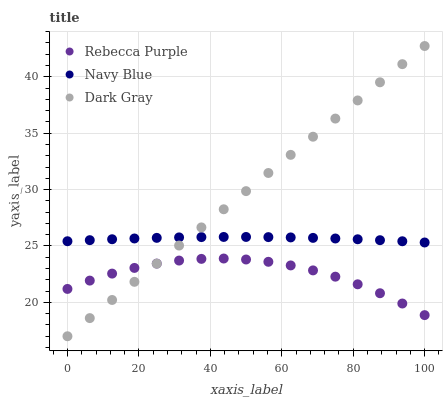Does Rebecca Purple have the minimum area under the curve?
Answer yes or no. Yes. Does Dark Gray have the maximum area under the curve?
Answer yes or no. Yes. Does Navy Blue have the minimum area under the curve?
Answer yes or no. No. Does Navy Blue have the maximum area under the curve?
Answer yes or no. No. Is Dark Gray the smoothest?
Answer yes or no. Yes. Is Rebecca Purple the roughest?
Answer yes or no. Yes. Is Navy Blue the smoothest?
Answer yes or no. No. Is Navy Blue the roughest?
Answer yes or no. No. Does Dark Gray have the lowest value?
Answer yes or no. Yes. Does Rebecca Purple have the lowest value?
Answer yes or no. No. Does Dark Gray have the highest value?
Answer yes or no. Yes. Does Navy Blue have the highest value?
Answer yes or no. No. Is Rebecca Purple less than Navy Blue?
Answer yes or no. Yes. Is Navy Blue greater than Rebecca Purple?
Answer yes or no. Yes. Does Dark Gray intersect Rebecca Purple?
Answer yes or no. Yes. Is Dark Gray less than Rebecca Purple?
Answer yes or no. No. Is Dark Gray greater than Rebecca Purple?
Answer yes or no. No. Does Rebecca Purple intersect Navy Blue?
Answer yes or no. No. 